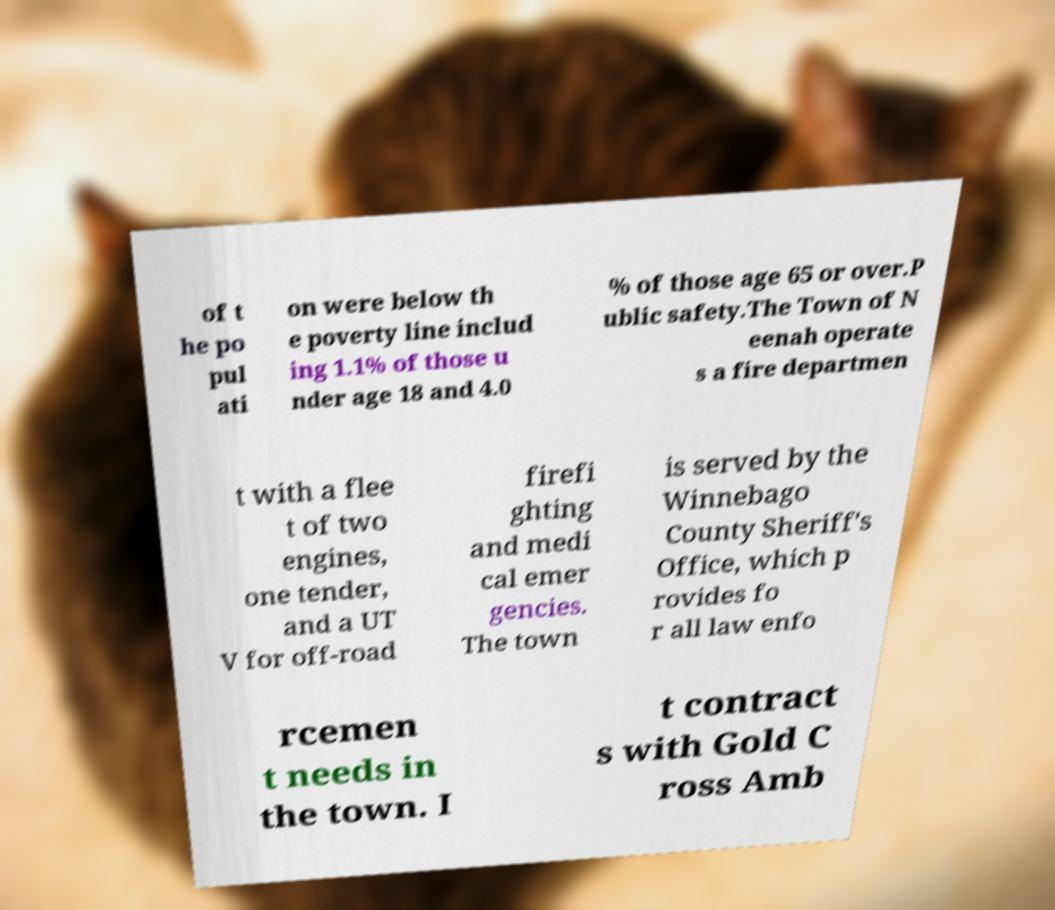Please read and relay the text visible in this image. What does it say? of t he po pul ati on were below th e poverty line includ ing 1.1% of those u nder age 18 and 4.0 % of those age 65 or over.P ublic safety.The Town of N eenah operate s a fire departmen t with a flee t of two engines, one tender, and a UT V for off-road firefi ghting and medi cal emer gencies. The town is served by the Winnebago County Sheriff's Office, which p rovides fo r all law enfo rcemen t needs in the town. I t contract s with Gold C ross Amb 